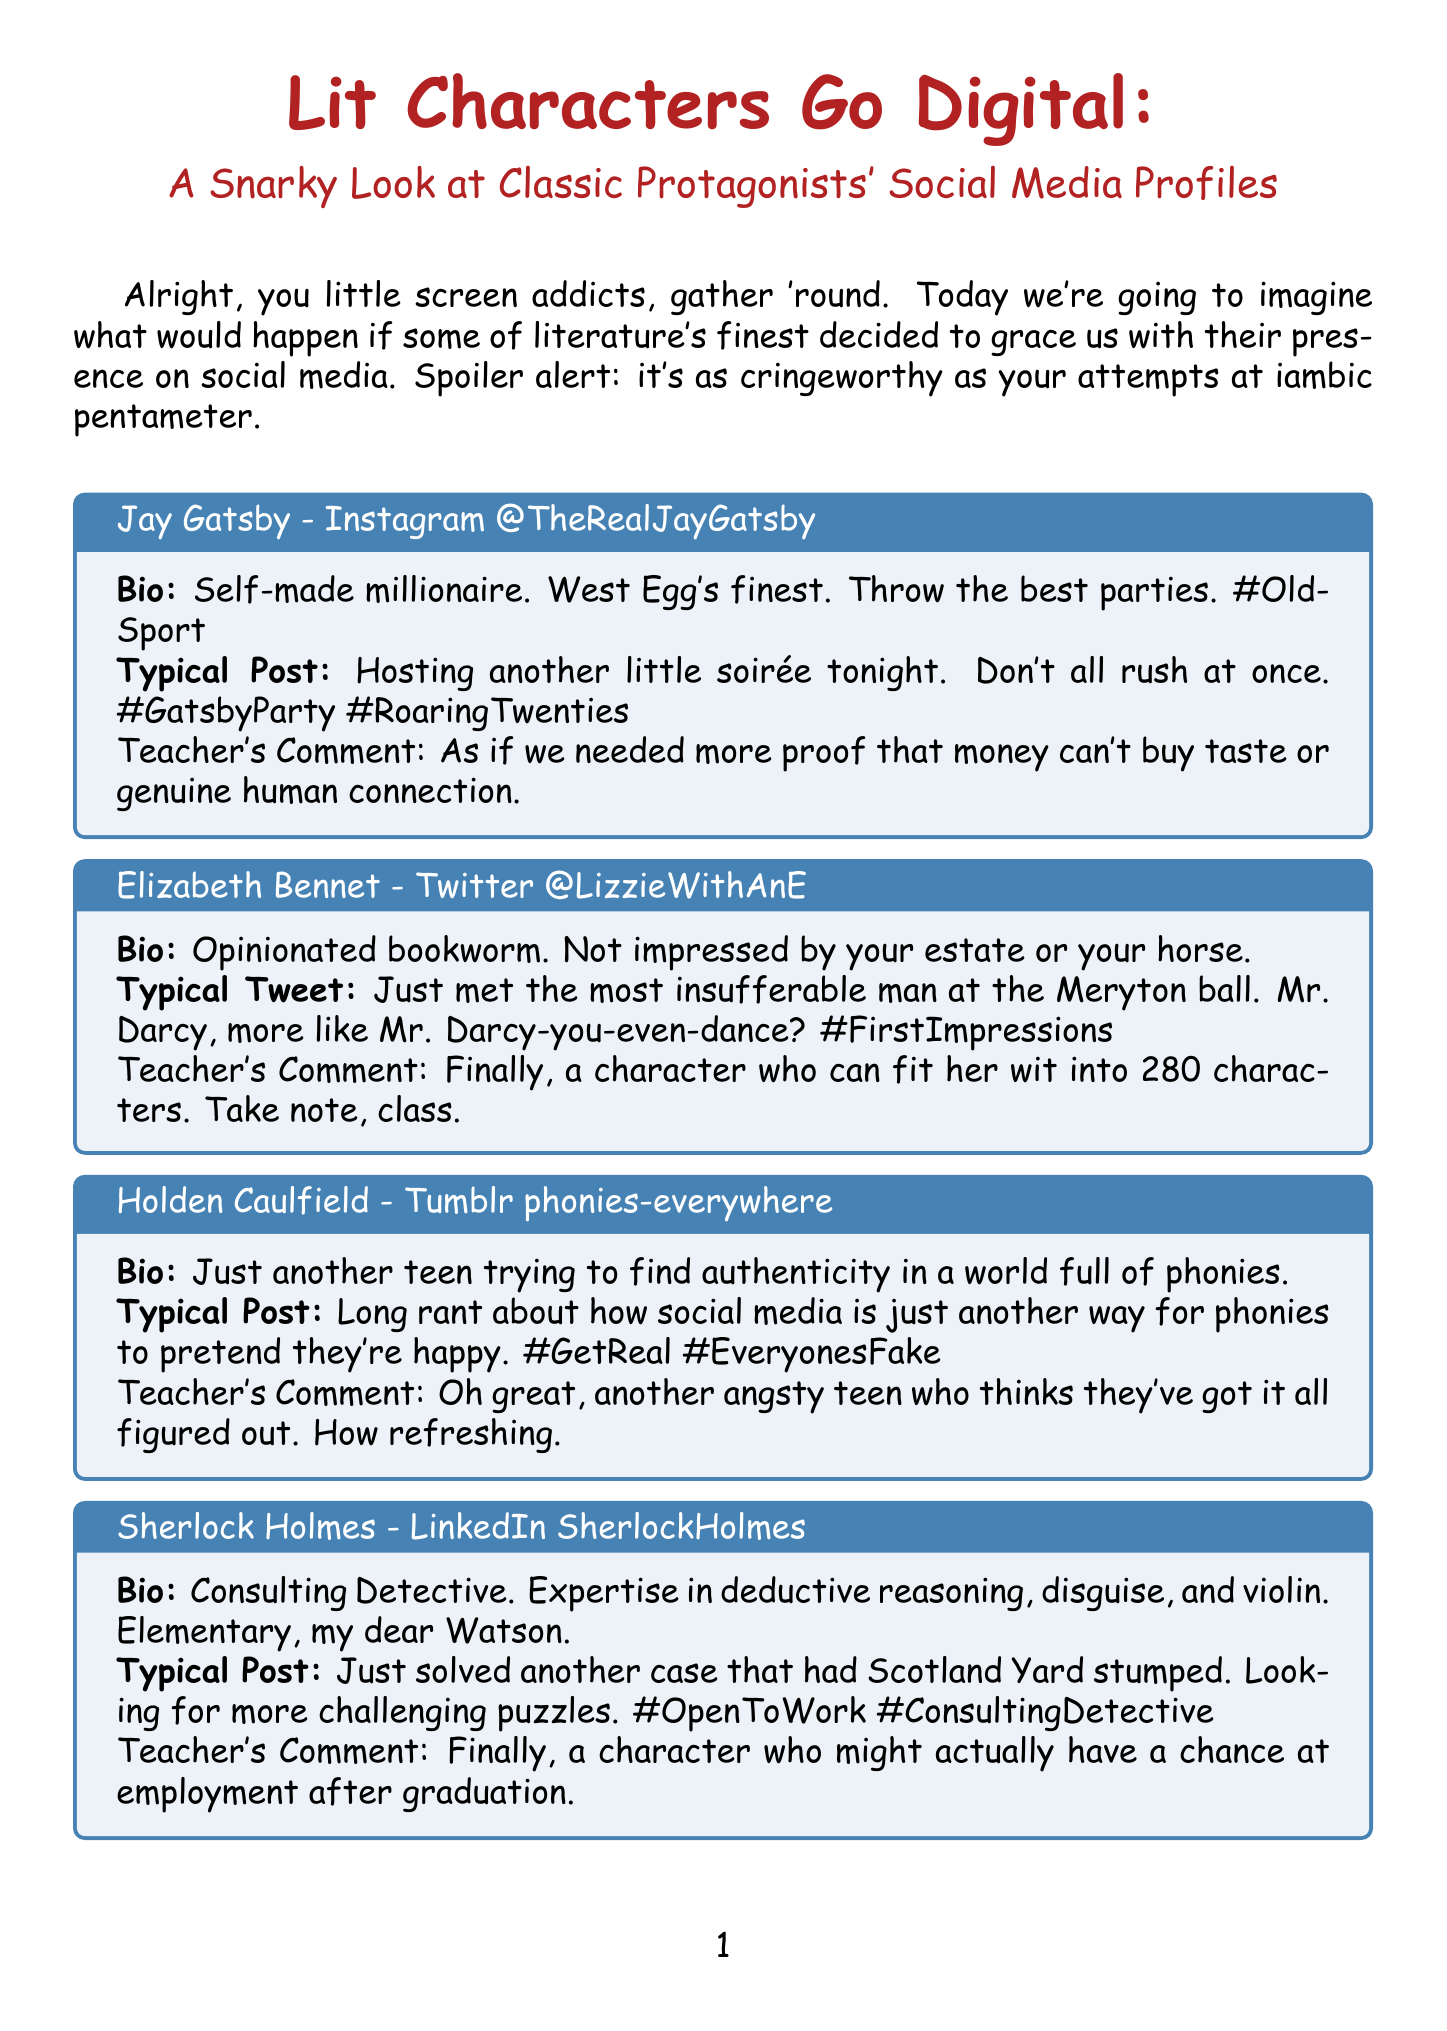What is the title of the newsletter? The title is explicitly stated at the beginning of the document.
Answer: Lit Characters Go Digital: A Snarky Look at Classic Protagonists' Social Media Profiles Who is the author of the character profile for Elizabeth Bennet? Elizabeth Bennet's profile is presented as a character from Pride and Prejudice.
Answer: Jane Austen What social media platform does Jay Gatsby use? The document lists specific platforms for each character.
Answer: Instagram What is Holden Caulfield's typical post about? Holden's typical post addresses his thoughts on social media and authenticity.
Answer: Rant about social media being fake Which character's bio mentions expertise in violin? The bio details for each character include unique skills or traits.
Answer: Sherlock Holmes What is the primary purpose of the class activity? The description of the activity outlines what students are expected to create.
Answer: Create a character’s social media profile How many grading criteria are listed for the class activity? The criteria for grading are explicitly numbered in the document.
Answer: Three Who is Jay Gatsby's username on Instagram? Each character's profile includes their specific username.
Answer: @TheRealJayGatsby What is the teacher's comment about Elizabeth Bennet? The document provides a teacher's commentary for each character's profile.
Answer: Finally, a character who can fit her wit into 280 characters. Take note, class 